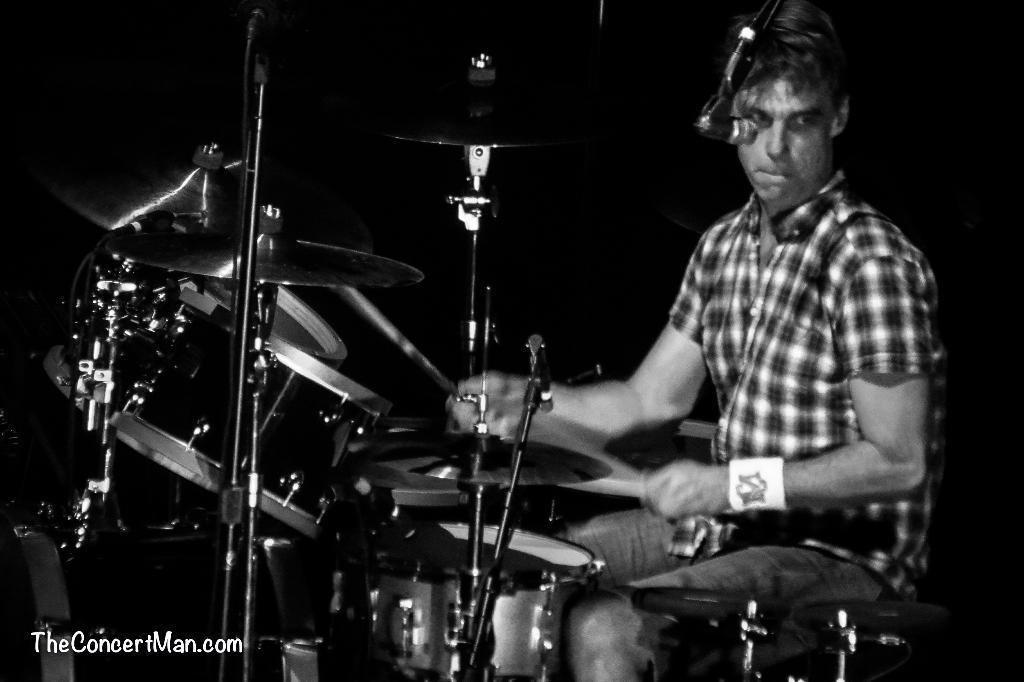Can you describe this image briefly? It is a black and white image. In this image we can see a person sitting and playing musical instruments. We can also see the text in the bottom left corner. 